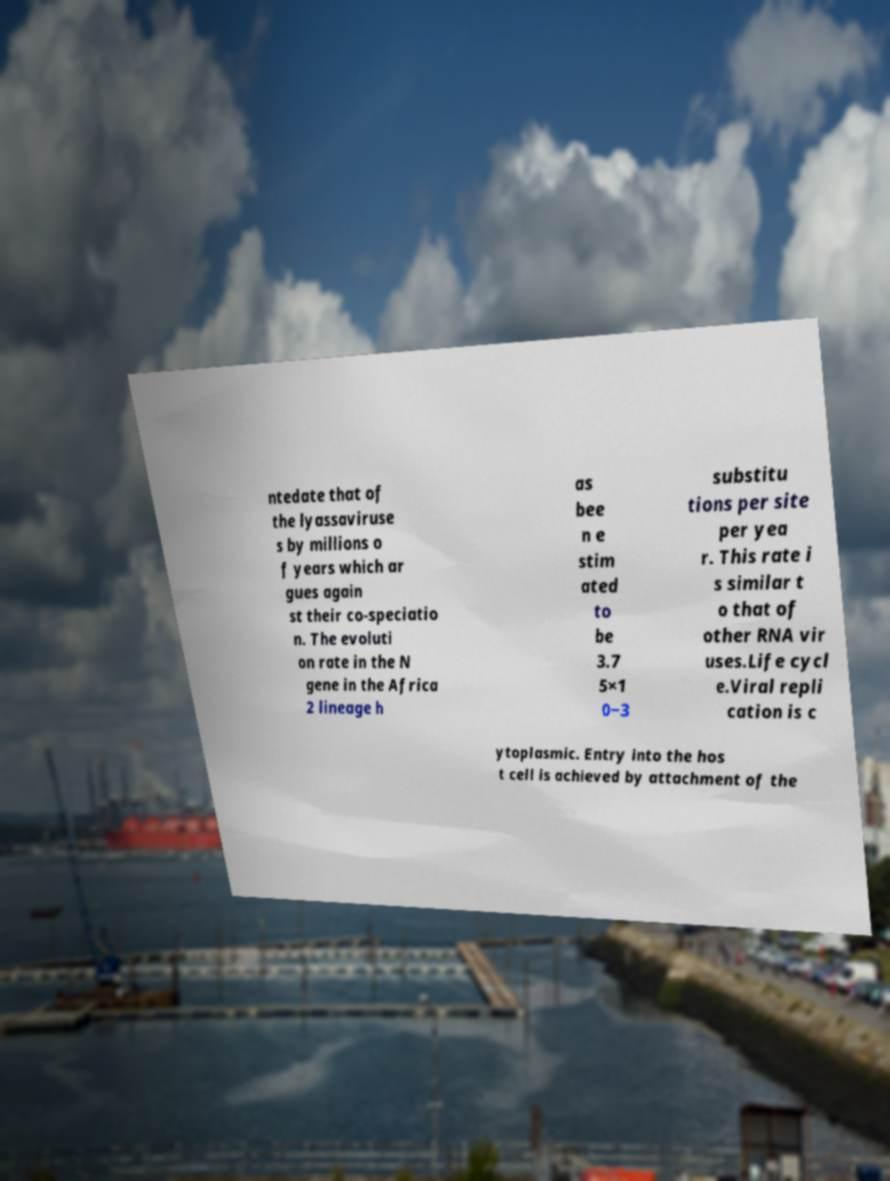Please read and relay the text visible in this image. What does it say? ntedate that of the lyassaviruse s by millions o f years which ar gues again st their co-speciatio n. The evoluti on rate in the N gene in the Africa 2 lineage h as bee n e stim ated to be 3.7 5×1 0−3 substitu tions per site per yea r. This rate i s similar t o that of other RNA vir uses.Life cycl e.Viral repli cation is c ytoplasmic. Entry into the hos t cell is achieved by attachment of the 